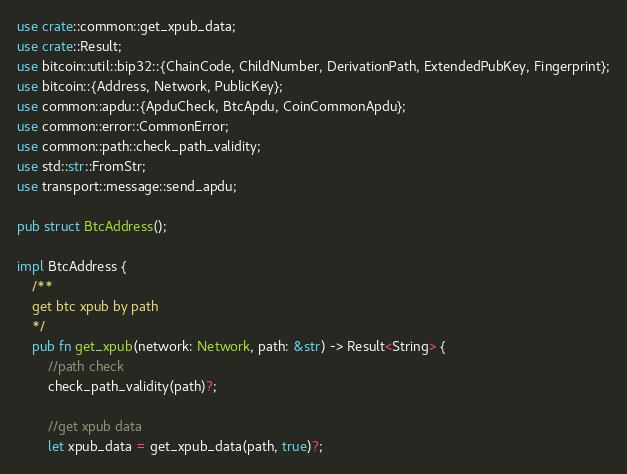<code> <loc_0><loc_0><loc_500><loc_500><_Rust_>use crate::common::get_xpub_data;
use crate::Result;
use bitcoin::util::bip32::{ChainCode, ChildNumber, DerivationPath, ExtendedPubKey, Fingerprint};
use bitcoin::{Address, Network, PublicKey};
use common::apdu::{ApduCheck, BtcApdu, CoinCommonApdu};
use common::error::CommonError;
use common::path::check_path_validity;
use std::str::FromStr;
use transport::message::send_apdu;

pub struct BtcAddress();

impl BtcAddress {
    /**
    get btc xpub by path
    */
    pub fn get_xpub(network: Network, path: &str) -> Result<String> {
        //path check
        check_path_validity(path)?;

        //get xpub data
        let xpub_data = get_xpub_data(path, true)?;</code> 